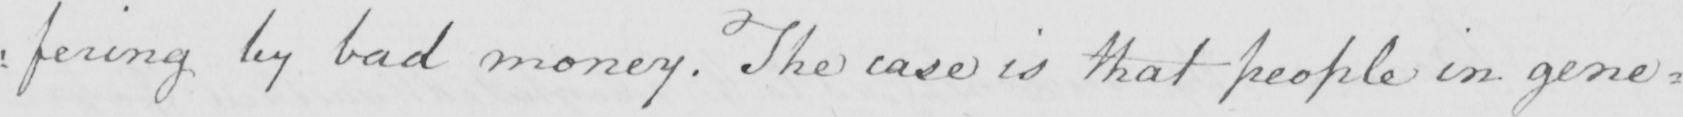Transcribe the text shown in this historical manuscript line. : fering by bad money . The case is that people in gene= 